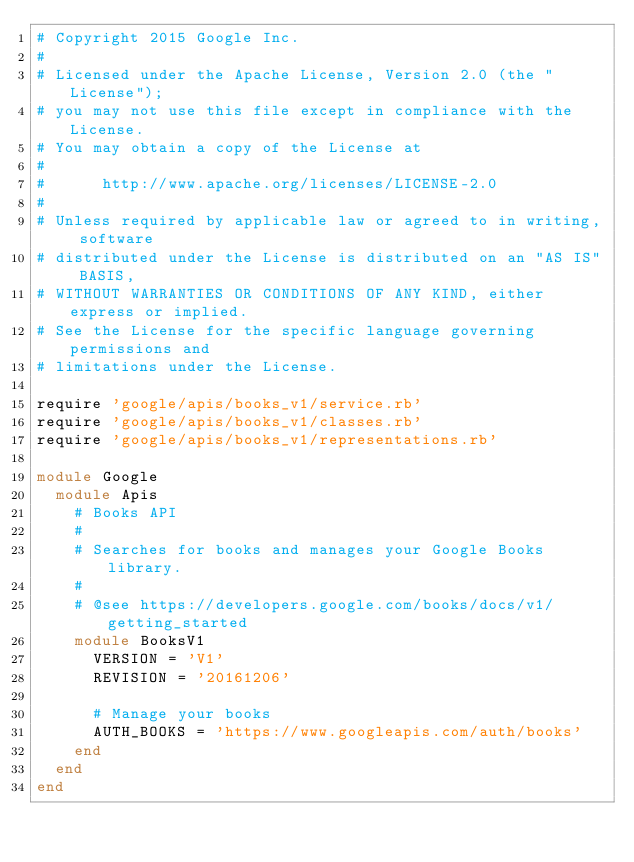Convert code to text. <code><loc_0><loc_0><loc_500><loc_500><_Ruby_># Copyright 2015 Google Inc.
#
# Licensed under the Apache License, Version 2.0 (the "License");
# you may not use this file except in compliance with the License.
# You may obtain a copy of the License at
#
#      http://www.apache.org/licenses/LICENSE-2.0
#
# Unless required by applicable law or agreed to in writing, software
# distributed under the License is distributed on an "AS IS" BASIS,
# WITHOUT WARRANTIES OR CONDITIONS OF ANY KIND, either express or implied.
# See the License for the specific language governing permissions and
# limitations under the License.

require 'google/apis/books_v1/service.rb'
require 'google/apis/books_v1/classes.rb'
require 'google/apis/books_v1/representations.rb'

module Google
  module Apis
    # Books API
    #
    # Searches for books and manages your Google Books library.
    #
    # @see https://developers.google.com/books/docs/v1/getting_started
    module BooksV1
      VERSION = 'V1'
      REVISION = '20161206'

      # Manage your books
      AUTH_BOOKS = 'https://www.googleapis.com/auth/books'
    end
  end
end
</code> 